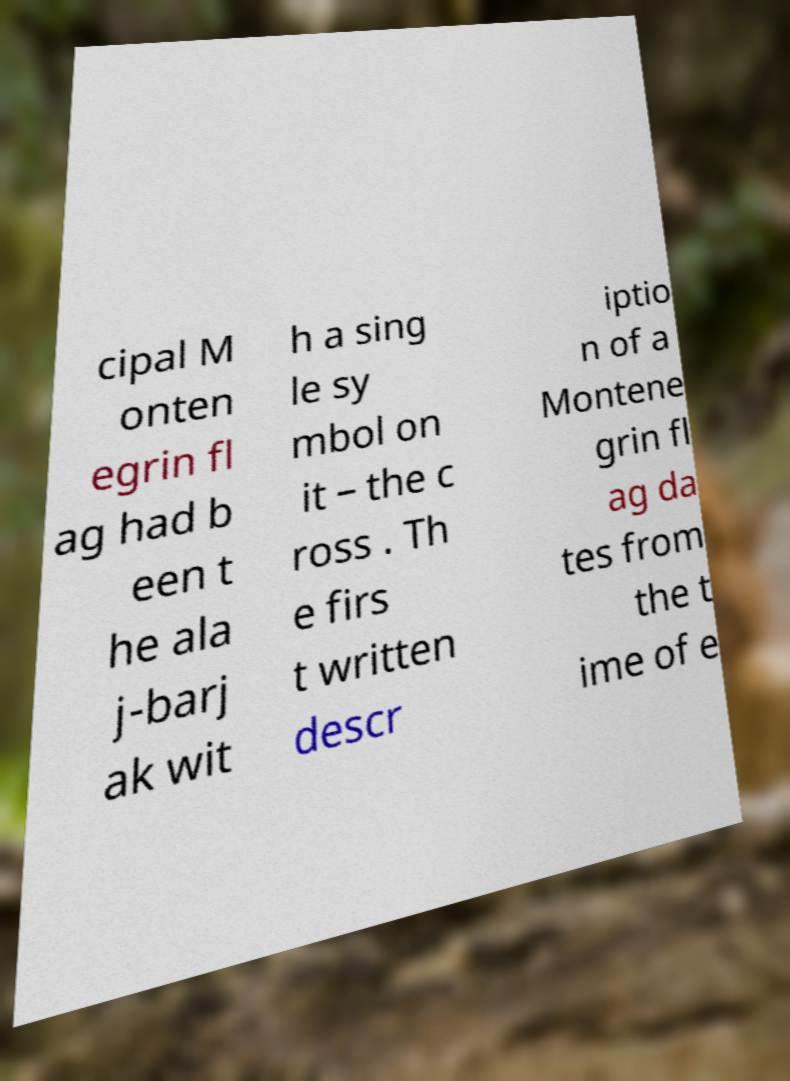Could you assist in decoding the text presented in this image and type it out clearly? cipal M onten egrin fl ag had b een t he ala j-barj ak wit h a sing le sy mbol on it – the c ross . Th e firs t written descr iptio n of a Montene grin fl ag da tes from the t ime of e 